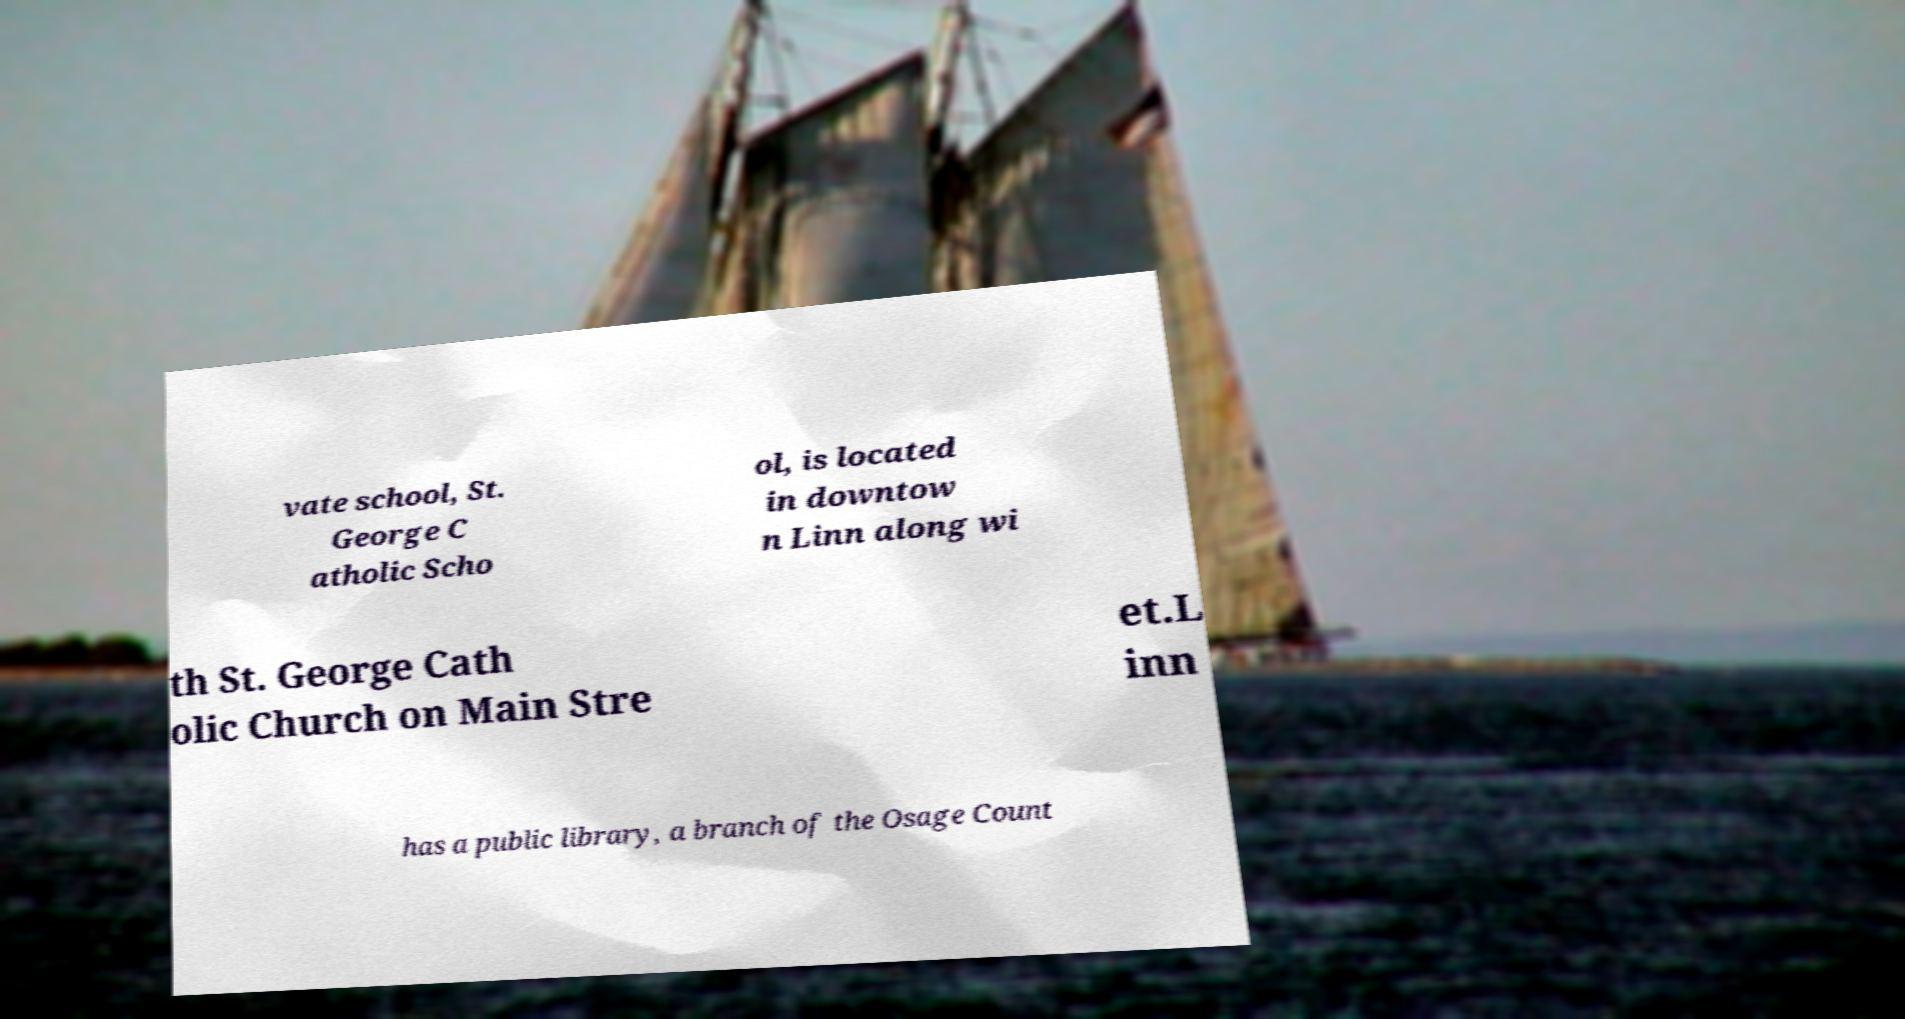I need the written content from this picture converted into text. Can you do that? vate school, St. George C atholic Scho ol, is located in downtow n Linn along wi th St. George Cath olic Church on Main Stre et.L inn has a public library, a branch of the Osage Count 